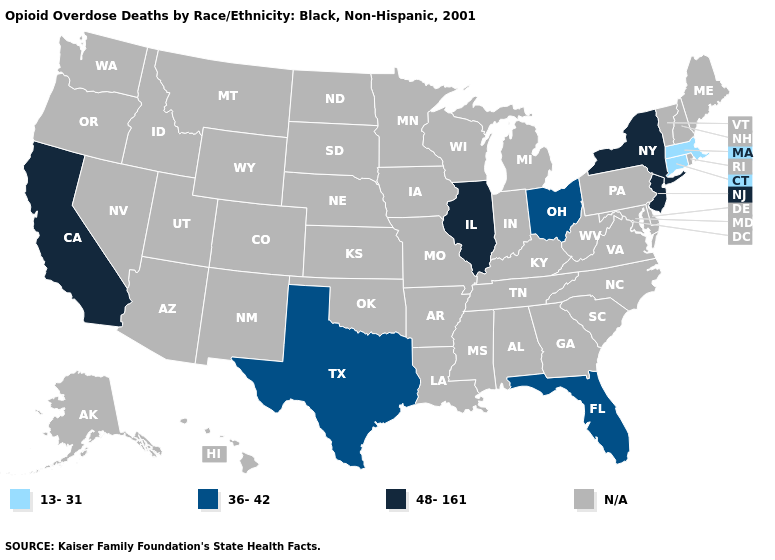Name the states that have a value in the range 48-161?
Quick response, please. California, Illinois, New Jersey, New York. Does California have the highest value in the USA?
Keep it brief. Yes. How many symbols are there in the legend?
Give a very brief answer. 4. Name the states that have a value in the range 48-161?
Concise answer only. California, Illinois, New Jersey, New York. What is the value of Hawaii?
Keep it brief. N/A. Does Ohio have the lowest value in the MidWest?
Keep it brief. Yes. Does the map have missing data?
Give a very brief answer. Yes. What is the value of Idaho?
Keep it brief. N/A. What is the lowest value in the USA?
Concise answer only. 13-31. What is the value of North Carolina?
Short answer required. N/A. Among the states that border West Virginia , which have the lowest value?
Concise answer only. Ohio. Name the states that have a value in the range 13-31?
Write a very short answer. Connecticut, Massachusetts. Which states have the highest value in the USA?
Write a very short answer. California, Illinois, New Jersey, New York. 